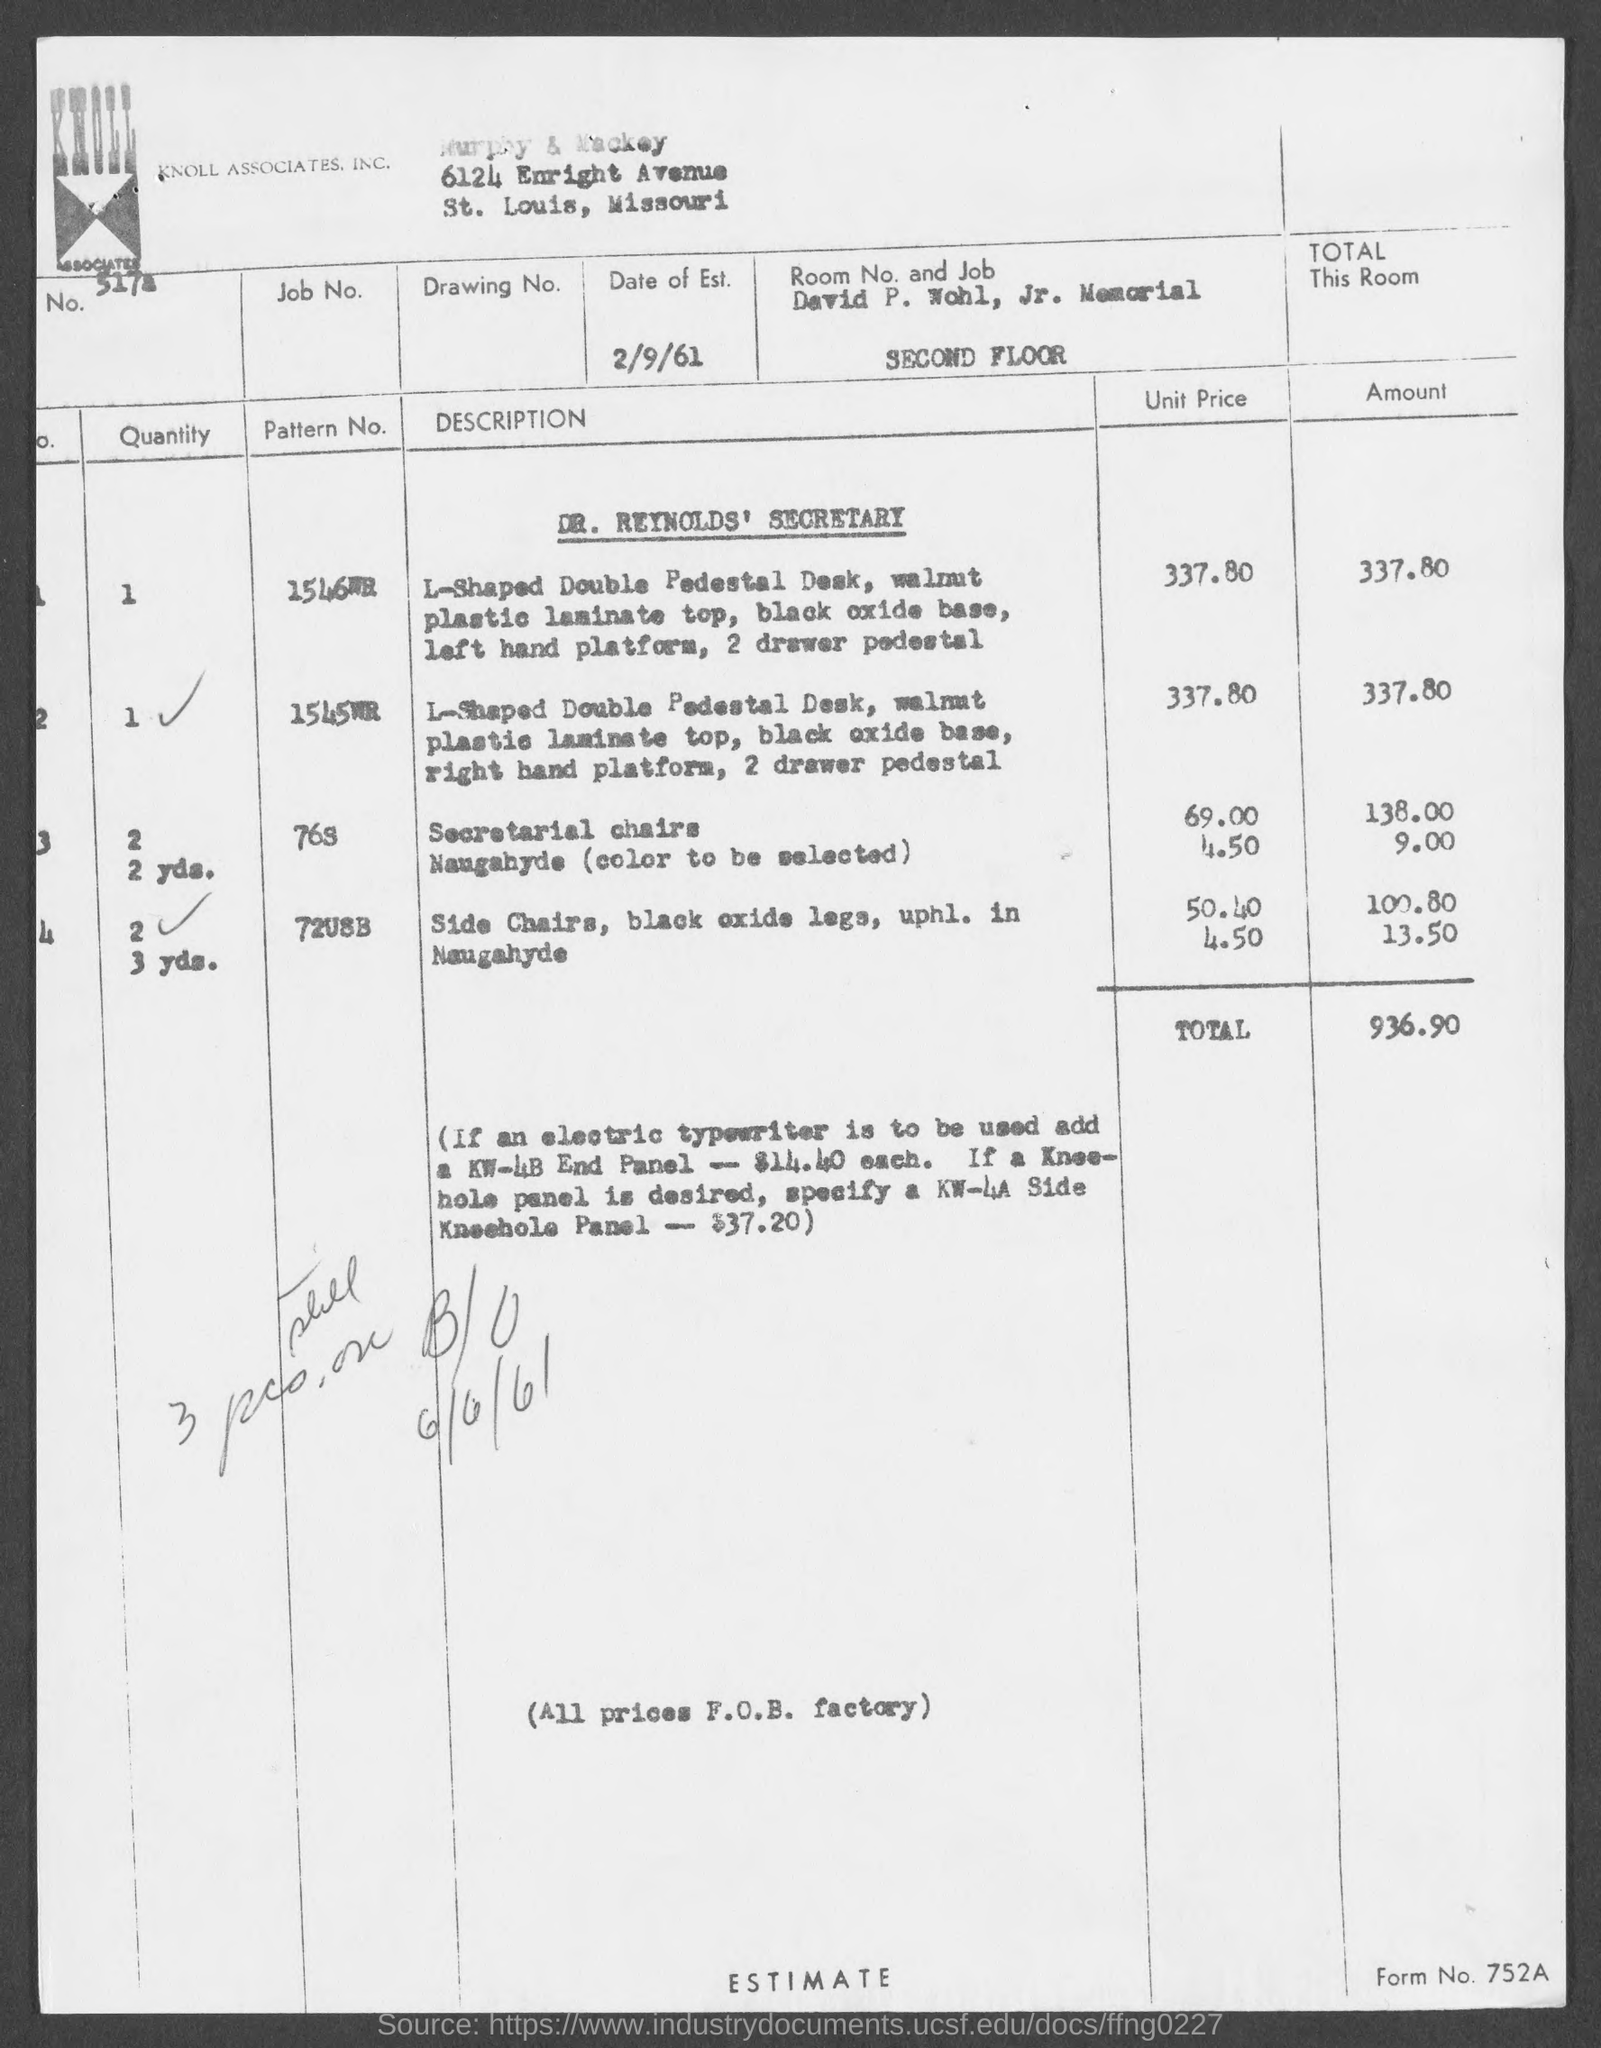Point out several critical features in this image. The total amount is $936.90. Murphy & Mackey are located in the state of Missouri. 